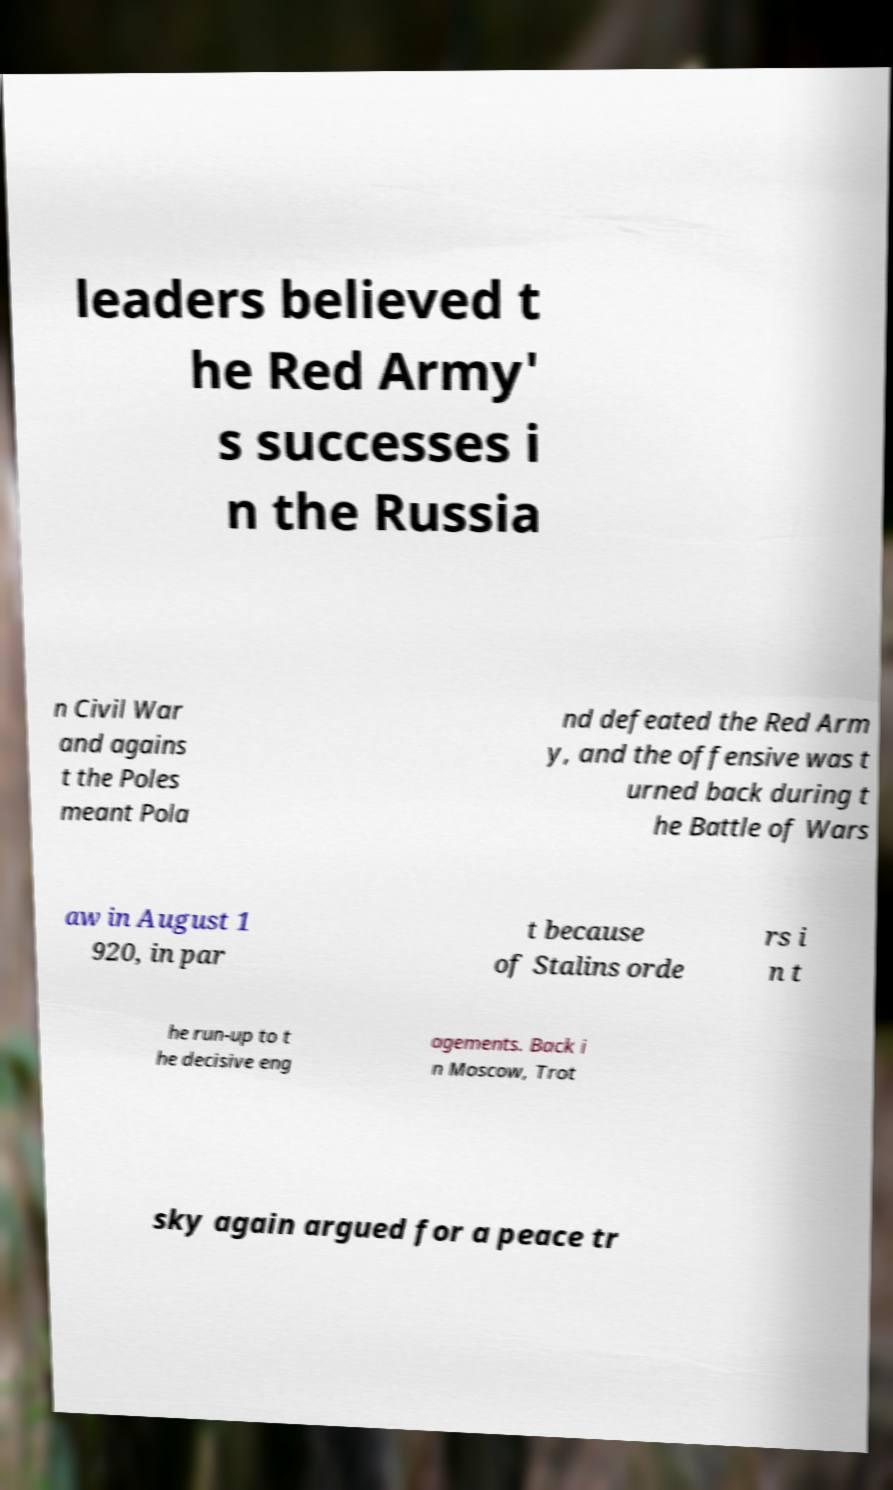For documentation purposes, I need the text within this image transcribed. Could you provide that? leaders believed t he Red Army' s successes i n the Russia n Civil War and agains t the Poles meant Pola nd defeated the Red Arm y, and the offensive was t urned back during t he Battle of Wars aw in August 1 920, in par t because of Stalins orde rs i n t he run-up to t he decisive eng agements. Back i n Moscow, Trot sky again argued for a peace tr 